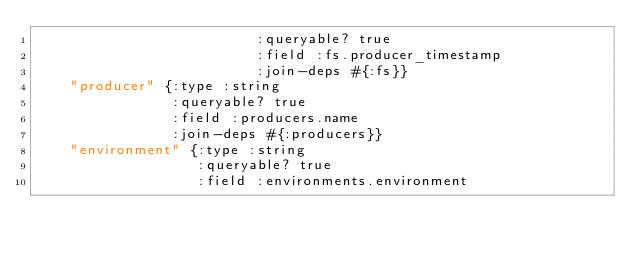<code> <loc_0><loc_0><loc_500><loc_500><_Clojure_>                          :queryable? true
                          :field :fs.producer_timestamp
                          :join-deps #{:fs}}
    "producer" {:type :string
                :queryable? true
                :field :producers.name
                :join-deps #{:producers}}
    "environment" {:type :string
                   :queryable? true
                   :field :environments.environment</code> 